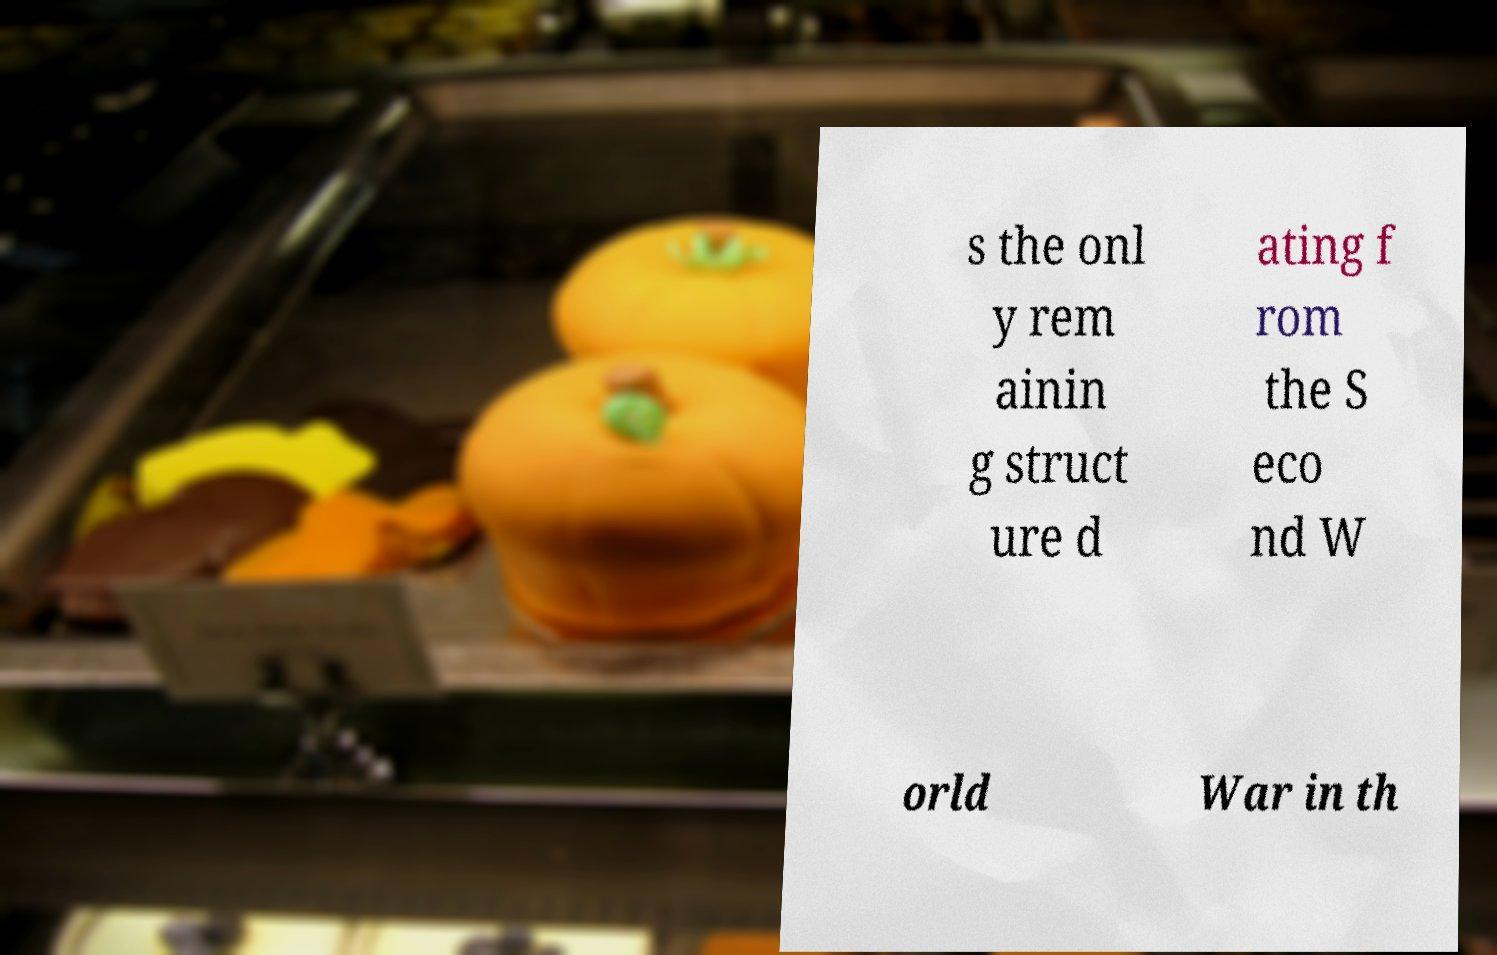What messages or text are displayed in this image? I need them in a readable, typed format. s the onl y rem ainin g struct ure d ating f rom the S eco nd W orld War in th 